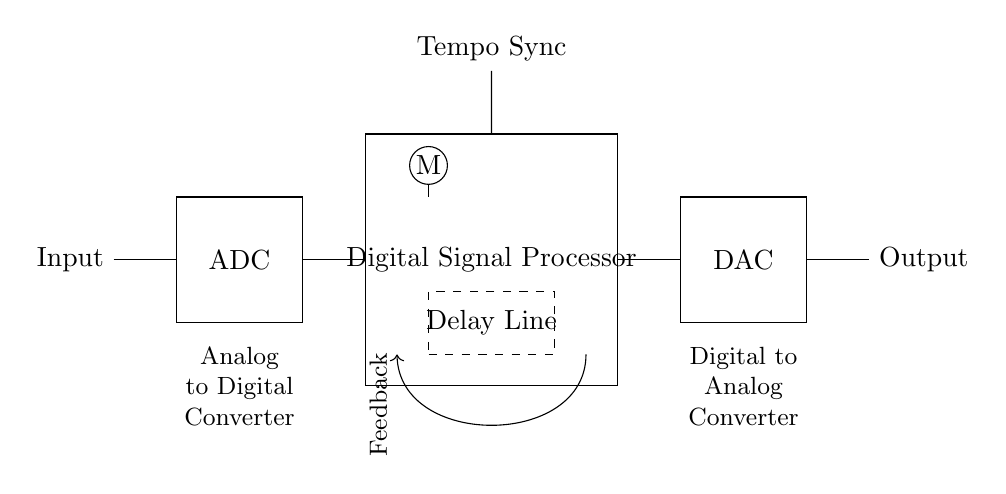What is the primary function of the ADC in this circuit? The ADC converts the analog input signal into a digital format, allowing the digital signal processor to process it.
Answer: Convert analog to digital What does the digital signal processor manage in this setup? The digital signal processor is responsible for processing the digital signal, applying effects, and creating the delay based on the tempo sync input.
Answer: Signal processing How is the feedback in the circuit represented? The feedback is indicated by the arrow that loops back from the output of the delay line to the input of the digital signal processor.
Answer: With an arrow What is the purpose of the delay line in this circuit? The delay line is used to introduce a time delay in the signal, allowing for rhythmic echoes to be created based on the processed signals.
Answer: Create echoes What component ensures that the output is in an audible format? The DAC (Digital to Analog Converter) is responsible for converting the processed digital signal back into an analog format for output.
Answer: DAC 